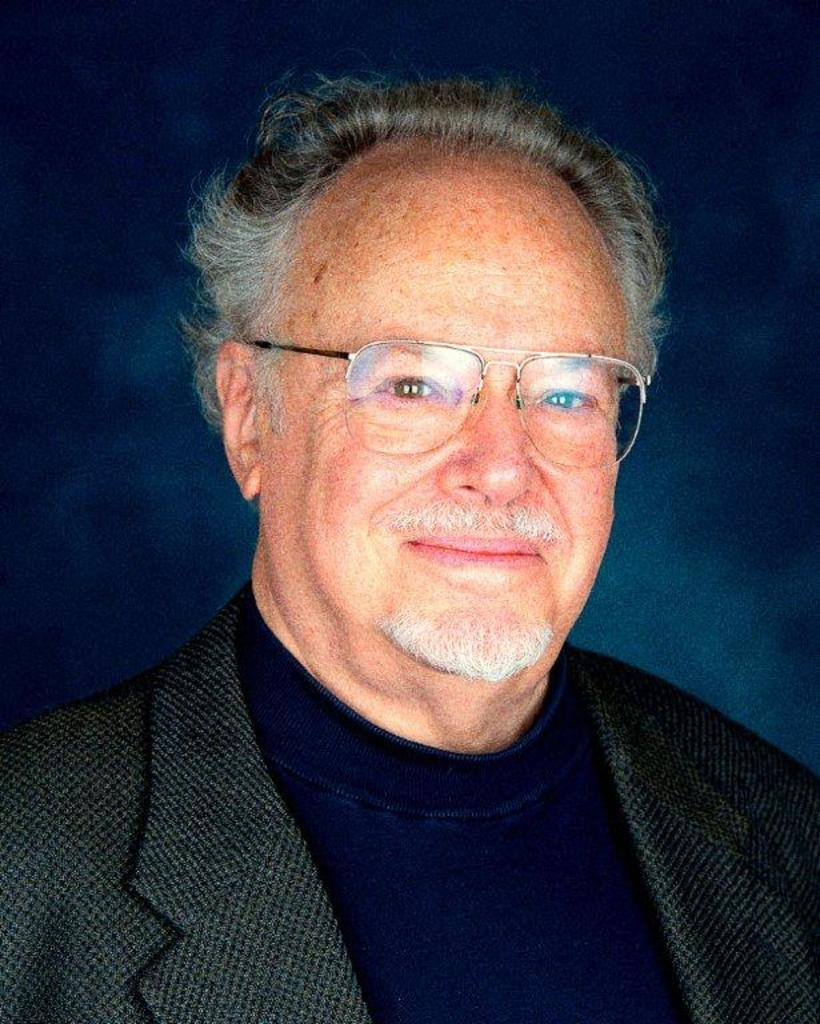What is the color or tone of the background in the image? The background of the image is dark. Who or what is the main subject in the image? There is a man in the middle of the image. What is the facial expression of the man in the image? The man has a smiling face. What type of clothing is the man wearing on his upper body? The man is wearing a coat and a T-shirt. What accessory is the man wearing on his face? The man is wearing spectacles. What type of scent can be detected in the image? There is no mention of a scent in the image, so it cannot be determined from the image. 